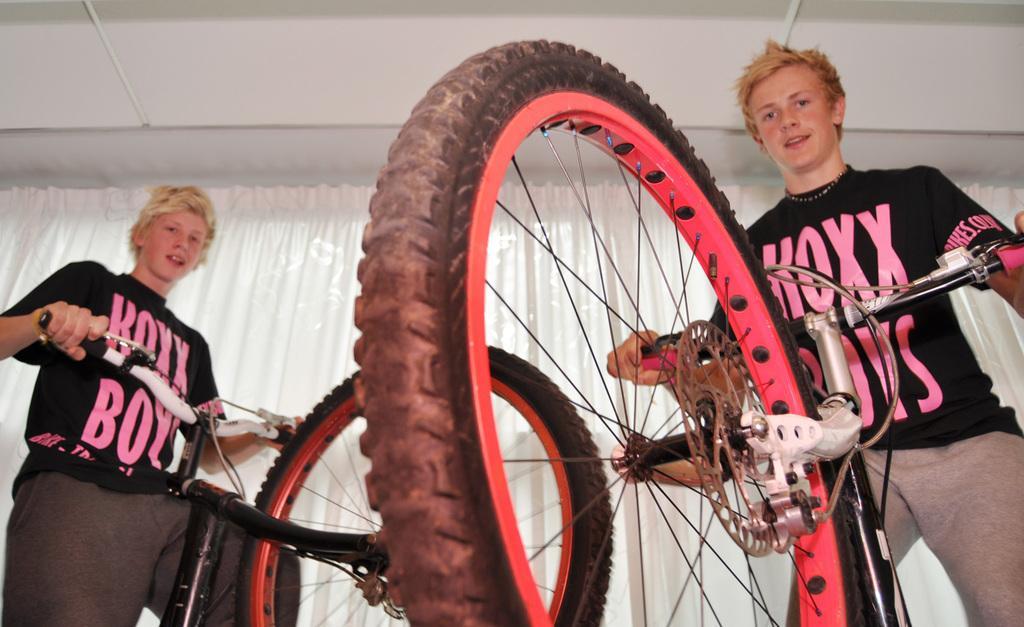In one or two sentences, can you explain what this image depicts? On the left side a boy is playing with a cycle, he wore a black color t-shirt. On the right side another boy is holding a cycle. This is the curtain in the middle of an image. 